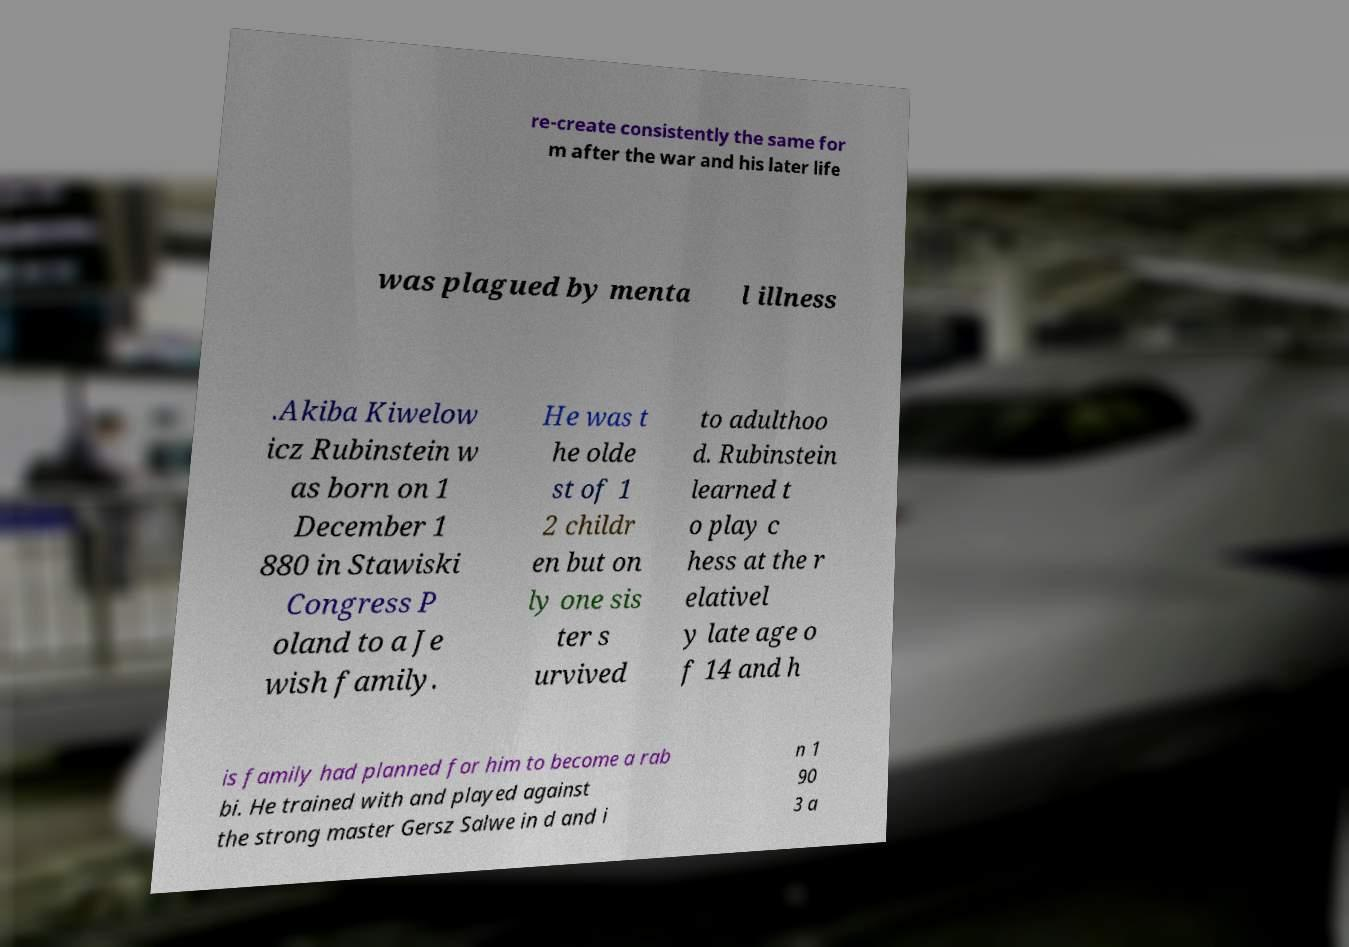Please read and relay the text visible in this image. What does it say? re-create consistently the same for m after the war and his later life was plagued by menta l illness .Akiba Kiwelow icz Rubinstein w as born on 1 December 1 880 in Stawiski Congress P oland to a Je wish family. He was t he olde st of 1 2 childr en but on ly one sis ter s urvived to adulthoo d. Rubinstein learned t o play c hess at the r elativel y late age o f 14 and h is family had planned for him to become a rab bi. He trained with and played against the strong master Gersz Salwe in d and i n 1 90 3 a 